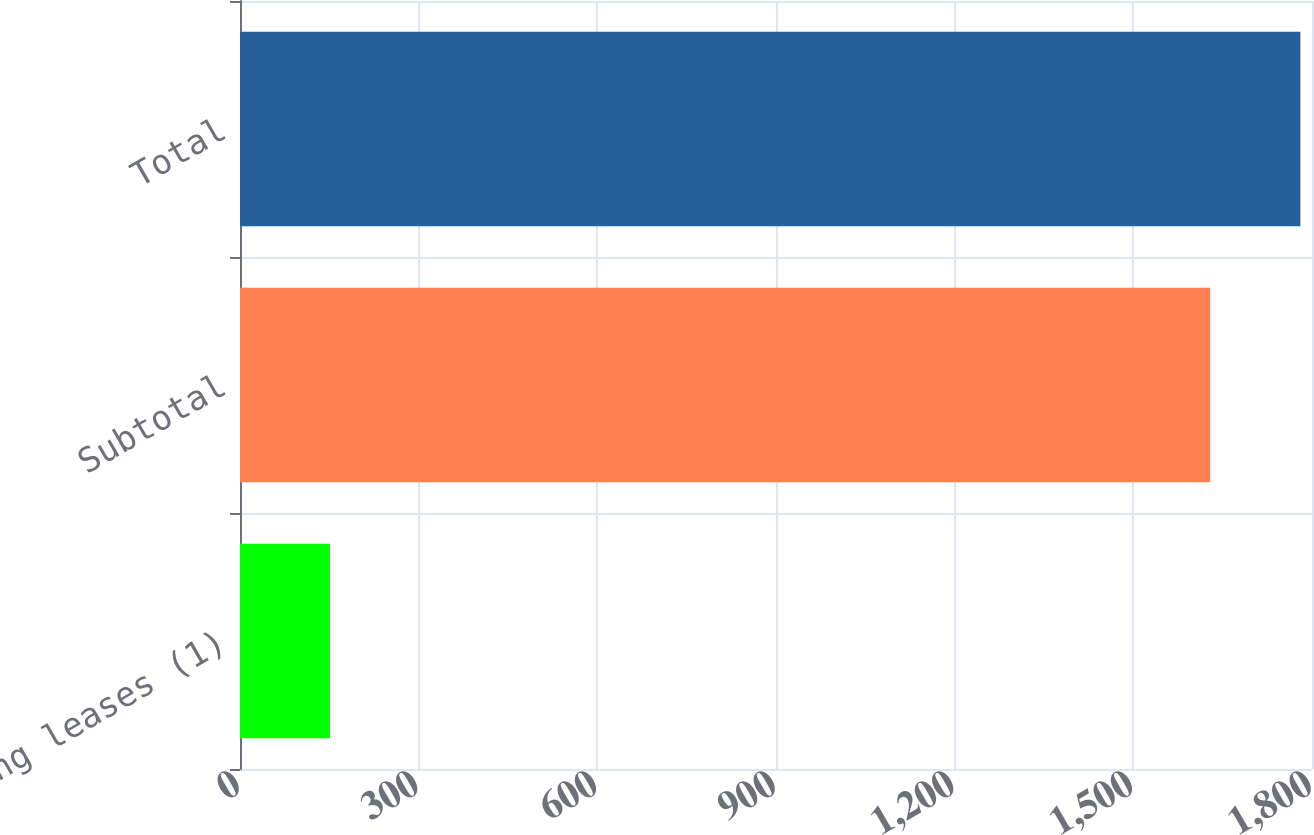Convert chart. <chart><loc_0><loc_0><loc_500><loc_500><bar_chart><fcel>Operating leases (1)<fcel>Subtotal<fcel>Total<nl><fcel>151<fcel>1629<fcel>1780.5<nl></chart> 